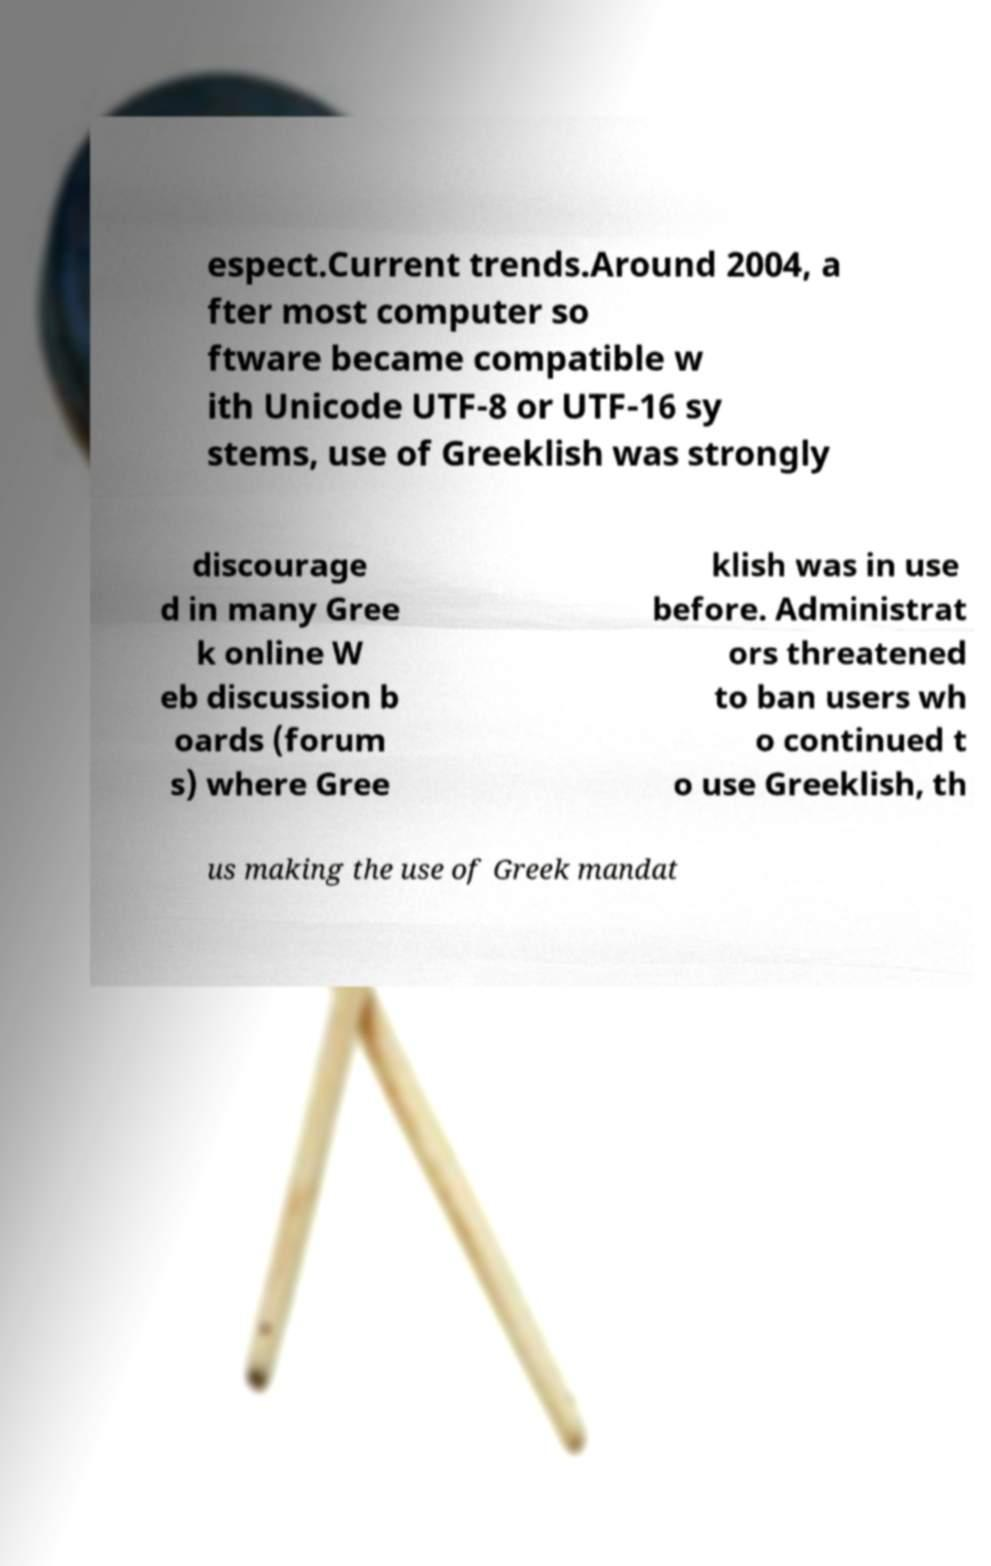Can you accurately transcribe the text from the provided image for me? espect.Current trends.Around 2004, a fter most computer so ftware became compatible w ith Unicode UTF-8 or UTF-16 sy stems, use of Greeklish was strongly discourage d in many Gree k online W eb discussion b oards (forum s) where Gree klish was in use before. Administrat ors threatened to ban users wh o continued t o use Greeklish, th us making the use of Greek mandat 